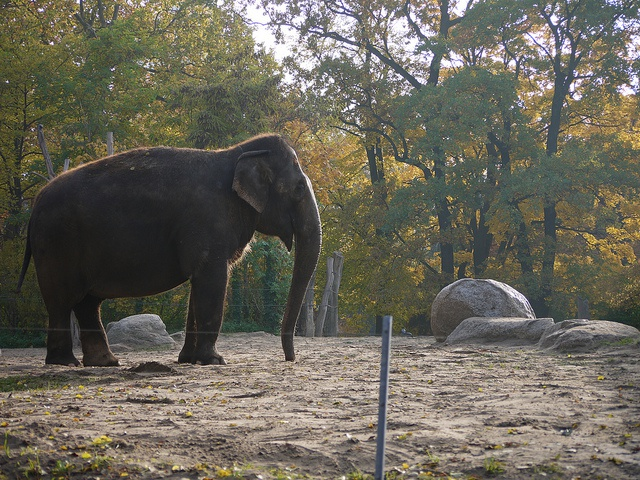Describe the objects in this image and their specific colors. I can see a elephant in darkgreen, black, and gray tones in this image. 